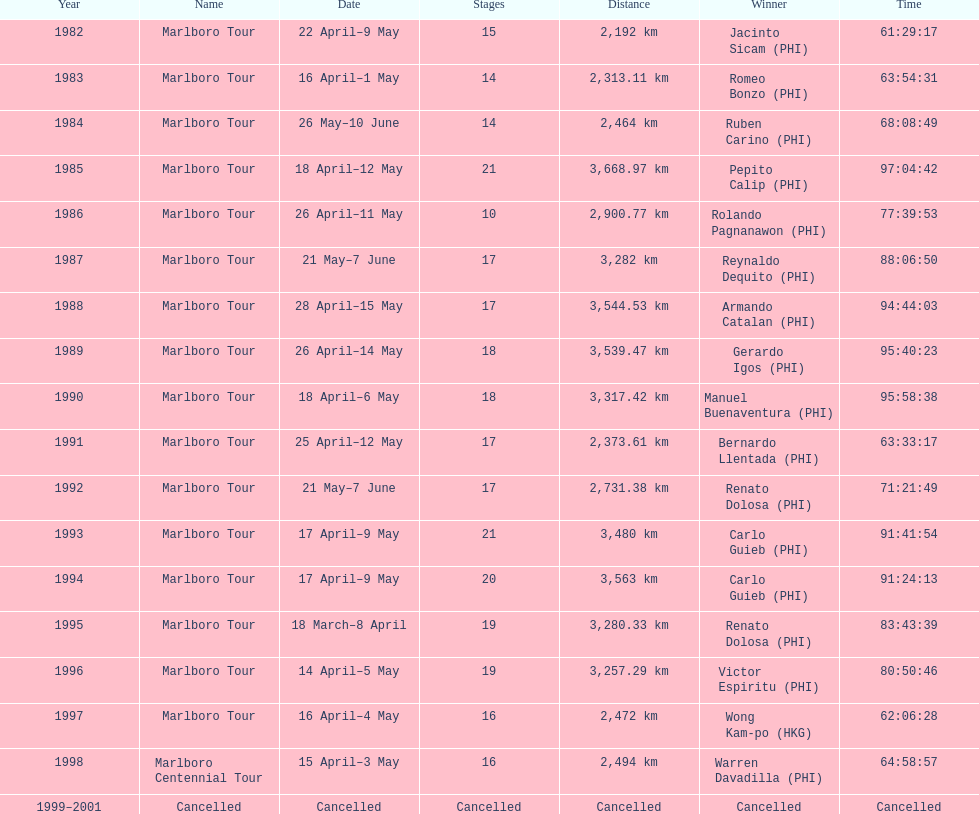Who was the only winner to have their time below 61:45:00? Jacinto Sicam. 